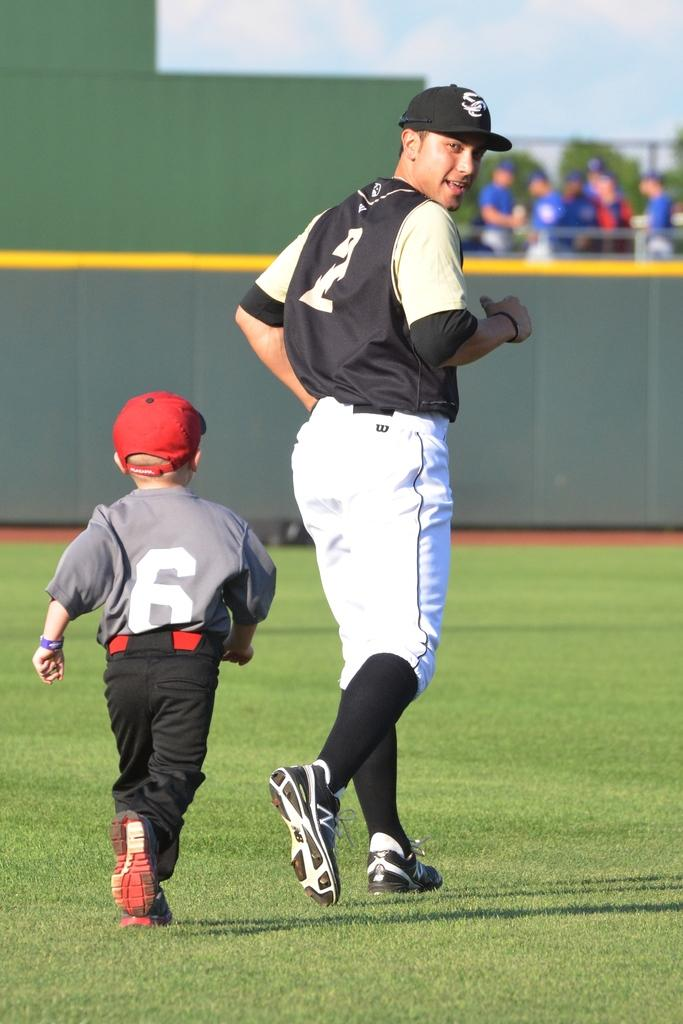Who is present in the image? There is a man and a child in the image. What are the man and child doing in the image? The man and child are running on the ground. What can be seen in the background of the image? There are persons standing in the background, trees, and the sky. What is the condition of the sky in the image? The sky is visible in the background, and clouds are present. What type of debt is the man discussing with the stranger in the image? There is no stranger present in the image, and therefore no discussion about debt can be observed. 